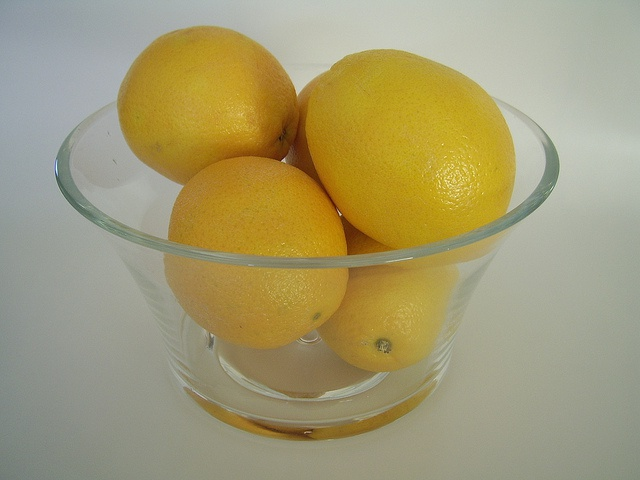Describe the objects in this image and their specific colors. I can see bowl in gray, olive, and darkgray tones, orange in gray and olive tones, orange in gray, olive, and orange tones, and orange in gray, olive, tan, and darkgray tones in this image. 